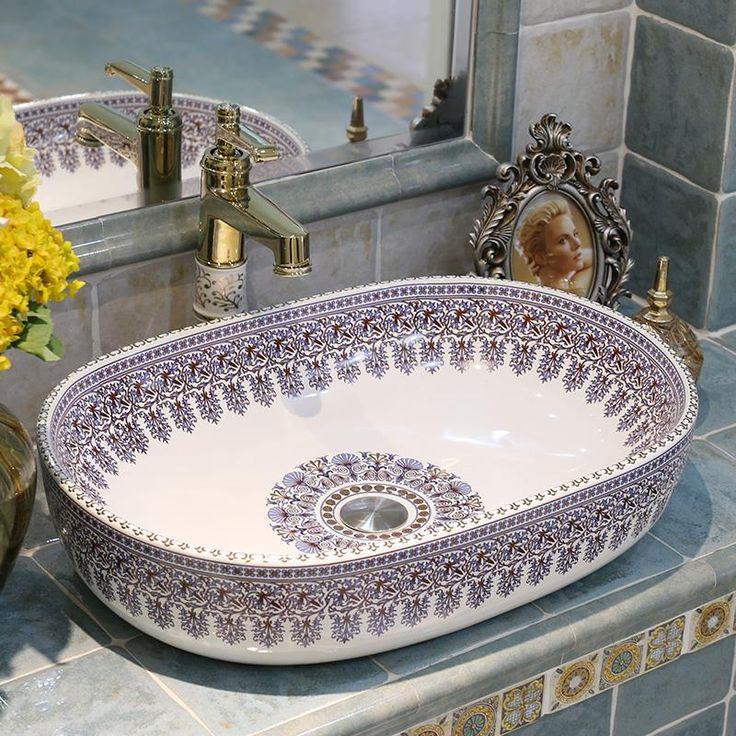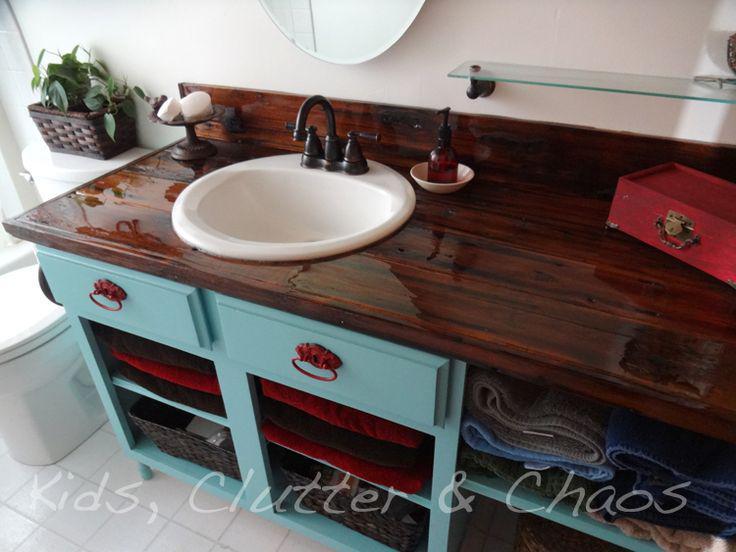The first image is the image on the left, the second image is the image on the right. For the images displayed, is the sentence "In one image a round white sink with dark faucets and curved spout is set into a wooden-topped bathroom vanity." factually correct? Answer yes or no. Yes. The first image is the image on the left, the second image is the image on the right. Considering the images on both sides, is "The sink in the image on the right is set in the counter." valid? Answer yes or no. Yes. 